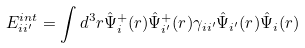Convert formula to latex. <formula><loc_0><loc_0><loc_500><loc_500>E _ { i i ^ { \prime } } ^ { i n t } = \int d ^ { 3 } r \hat { \Psi } ^ { + } _ { i } ( { r } ) \hat { \Psi } ^ { + } _ { i ^ { \prime } } ( { r } ) \gamma _ { i i ^ { \prime } } \hat { \Psi } _ { i ^ { \prime } } ( { r } ) \hat { \Psi } _ { i } ( { r } )</formula> 